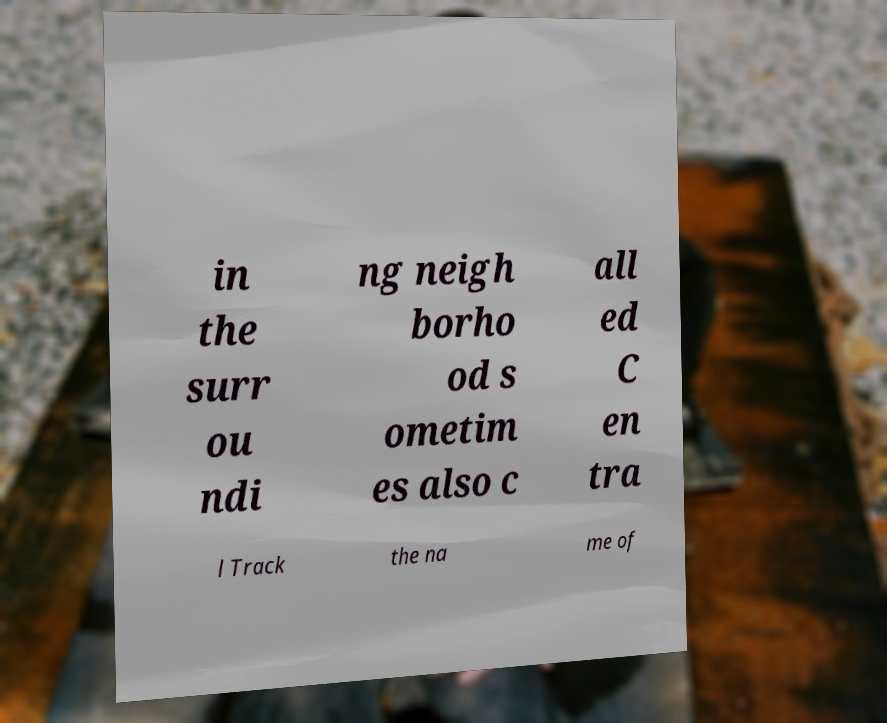Please identify and transcribe the text found in this image. in the surr ou ndi ng neigh borho od s ometim es also c all ed C en tra l Track the na me of 